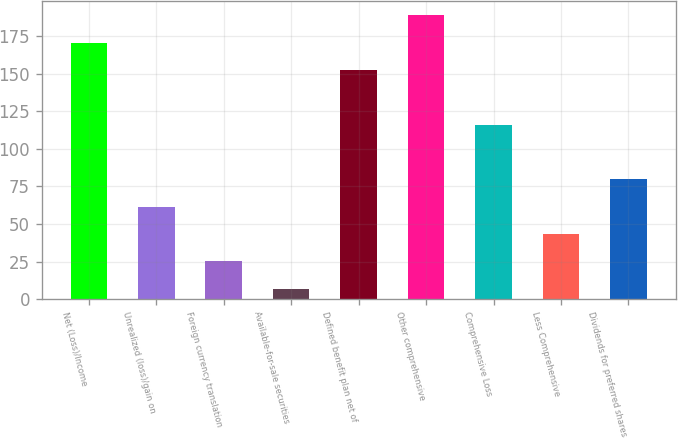Convert chart to OTSL. <chart><loc_0><loc_0><loc_500><loc_500><bar_chart><fcel>Net (Loss)/Income<fcel>Unrealized (loss)/gain on<fcel>Foreign currency translation<fcel>Available-for-sale securities<fcel>Defined benefit plan net of<fcel>Other comprehensive<fcel>Comprehensive Loss<fcel>Less Comprehensive<fcel>Dividends for preferred shares<nl><fcel>170.8<fcel>61.6<fcel>25.2<fcel>7<fcel>152.6<fcel>189<fcel>116.2<fcel>43.4<fcel>79.8<nl></chart> 